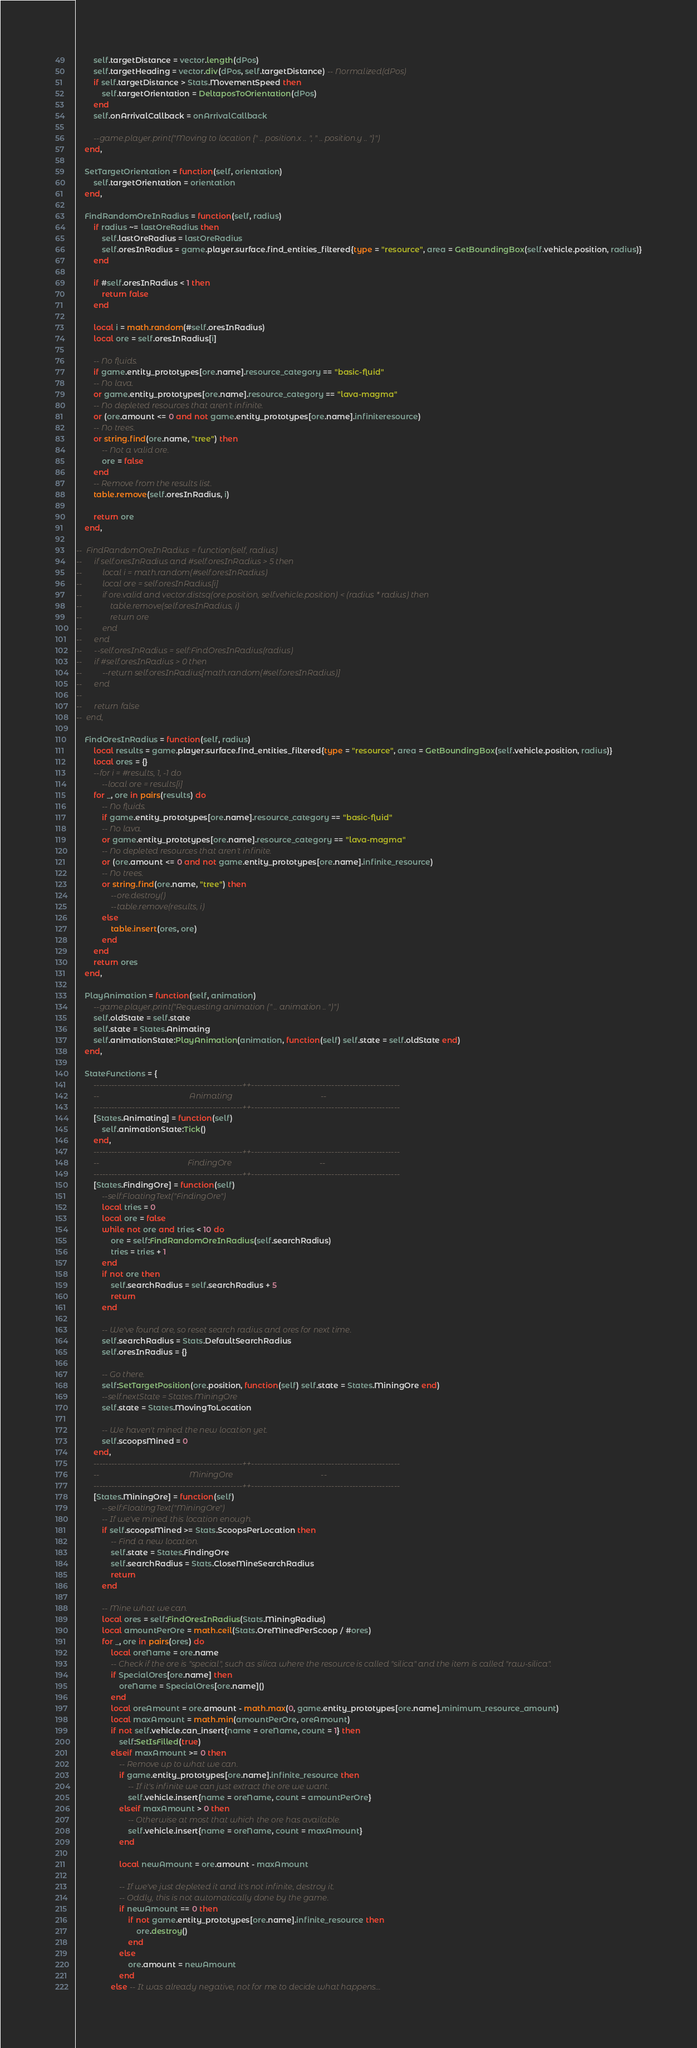Convert code to text. <code><loc_0><loc_0><loc_500><loc_500><_Lua_>		self.targetDistance = vector.length(dPos)
		self.targetHeading = vector.div(dPos, self.targetDistance) -- Normalized(dPos)
		if self.targetDistance > Stats.MovementSpeed then
			self.targetOrientation = DeltaposToOrientation(dPos)
		end
		self.onArrivalCallback = onArrivalCallback
		
		--game.player.print("Moving to location {" .. position.x .. ", " .. position.y .. "}")
	end,
	
	SetTargetOrientation = function(self, orientation)
		self.targetOrientation = orientation
	end,
	
	FindRandomOreInRadius = function(self, radius)
		if radius ~= lastOreRadius then
			self.lastOreRadius = lastOreRadius
			self.oresInRadius = game.player.surface.find_entities_filtered{type = "resource", area = GetBoundingBox(self.vehicle.position, radius)}
		end
		
		if #self.oresInRadius < 1 then
			return false
		end
		
		local i = math.random(#self.oresInRadius)
		local ore = self.oresInRadius[i]
		
		-- No fluids.
		if game.entity_prototypes[ore.name].resource_category == "basic-fluid"
		-- No lava.
		or game.entity_prototypes[ore.name].resource_category == "lava-magma"
		-- No depleted resources that aren't infinite.
		or (ore.amount <= 0 and not game.entity_prototypes[ore.name].infiniteresource)
		-- No trees.
		or string.find(ore.name, "tree") then
			-- Not a valid ore.
			ore = false
		end
		-- Remove from the results list.
		table.remove(self.oresInRadius, i)
		
		return ore
	end,
	
-- 	FindRandomOreInRadius = function(self, radius)
-- 		if self.oresInRadius and #self.oresInRadius > 5 then
-- 			local i = math.random(#self.oresInRadius)
-- 			local ore = self.oresInRadius[i]
-- 			if ore.valid and vector.distsq(ore.position, self.vehicle.position) < (radius * radius) then
-- 				table.remove(self.oresInRadius, i)
-- 				return ore
-- 			end
-- 		end
-- 		--self.oresInRadius = self:FindOresInRadius(radius)
-- 		if #self.oresInRadius > 0 then
-- 			--return self.oresInRadius[math.random(#self.oresInRadius)]
-- 		end
-- 		
-- 		return false
-- 	end,

	FindOresInRadius = function(self, radius)
		local results = game.player.surface.find_entities_filtered{type = "resource", area = GetBoundingBox(self.vehicle.position, radius)}
		local ores = {}
		--for i = #results, 1, -1 do
			--local ore = results[i]
		for _, ore in pairs(results) do
			-- No fluids.
			if game.entity_prototypes[ore.name].resource_category == "basic-fluid"
			-- No lava.
			or game.entity_prototypes[ore.name].resource_category == "lava-magma"
			-- No depleted resources that aren't infinite.
			or (ore.amount <= 0 and not game.entity_prototypes[ore.name].infinite_resource)
			-- No trees.
			or string.find(ore.name, "tree") then
				--ore.destroy()
				--table.remove(results, i)
			else
				table.insert(ores, ore)
			end
		end
		return ores
	end,
	
	PlayAnimation = function(self, animation)
		--game.player.print("Requesting animation (" .. animation .. ")")
		self.oldState = self.state
		self.state = States.Animating
		self.animationState:PlayAnimation(animation, function(self) self.state = self.oldState end)
	end,
	
	StateFunctions = {
		--------------------------------------------------++--------------------------------------------------
		--										  	   Animating											--
		--------------------------------------------------++--------------------------------------------------
		[States.Animating] = function(self)
			self.animationState:Tick()
		end,
		--------------------------------------------------++--------------------------------------------------
		--										  	  FindingOre											--
		--------------------------------------------------++--------------------------------------------------
		[States.FindingOre] = function(self)
			--self:FloatingText("FindingOre")
			local tries = 0
			local ore = false
			while not ore and tries < 10 do
				ore = self:FindRandomOreInRadius(self.searchRadius)
				tries = tries + 1
			end
			if not ore then
				self.searchRadius = self.searchRadius + 5
				return
			end
			
			-- We've found ore, so reset search radius and ores for next time.
			self.searchRadius = Stats.DefaultSearchRadius
			self.oresInRadius = {}
			
			-- Go there.
			self:SetTargetPosition(ore.position, function(self) self.state = States.MiningOre end)
			--self.nextState = States.MiningOre
			self.state = States.MovingToLocation
			
			-- We haven't mined the new location yet.
			self.scoopsMined = 0
		end,
		--------------------------------------------------++--------------------------------------------------
		--										  	   MiningOre											--
		--------------------------------------------------++--------------------------------------------------
		[States.MiningOre] = function(self)
			--self:FloatingText("MiningOre")
			-- If we've mined this location enough.
			if self.scoopsMined >= Stats.ScoopsPerLocation then
				-- Find a new location.
				self.state = States.FindingOre
				self.searchRadius = Stats.CloseMineSearchRadius
				return
			end
			
			-- Mine what we can.
			local ores = self:FindOresInRadius(Stats.MiningRadius)
			local amountPerOre = math.ceil(Stats.OreMinedPerScoop / #ores)
			for _, ore in pairs(ores) do
				local oreName = ore.name
				-- Check if the ore is "special", such as silica where the resource is called "silica" and the item is called "raw-silica".
				if SpecialOres[ore.name] then
					oreName = SpecialOres[ore.name]()
				end
				local oreAmount = ore.amount - math.max(0, game.entity_prototypes[ore.name].minimum_resource_amount)
				local maxAmount = math.min(amountPerOre, oreAmount)
				if not self.vehicle.can_insert{name = oreName, count = 1} then
					self:SetIsFilled(true)
				elseif maxAmount >= 0 then
					-- Remove up to what we can.
					if game.entity_prototypes[ore.name].infinite_resource then
						-- If it's infinite we can just extract the ore we want.
						self.vehicle.insert{name = oreName, count = amountPerOre}
					elseif maxAmount > 0 then
						-- Otherwise at most that which the ore has available.
						self.vehicle.insert{name = oreName, count = maxAmount}
					end
					
					local newAmount = ore.amount - maxAmount
					
					-- If we've just depleted it and it's not infinite, destroy it.
					-- Oddly, this is not automatically done by the game.
					if newAmount == 0 then
						if not game.entity_prototypes[ore.name].infinite_resource then
							ore.destroy()
						end
					else
						ore.amount = newAmount
					end
				else -- It was already negative, not for me to decide what happens...</code> 